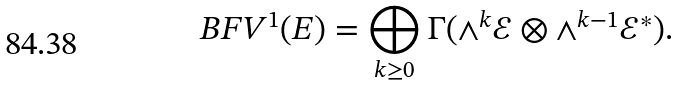Convert formula to latex. <formula><loc_0><loc_0><loc_500><loc_500>B F V ^ { 1 } ( E ) = \bigoplus _ { k \geq 0 } \Gamma ( \wedge ^ { k } \mathcal { E } \otimes \wedge ^ { k - 1 } \mathcal { E } ^ { * } ) .</formula> 